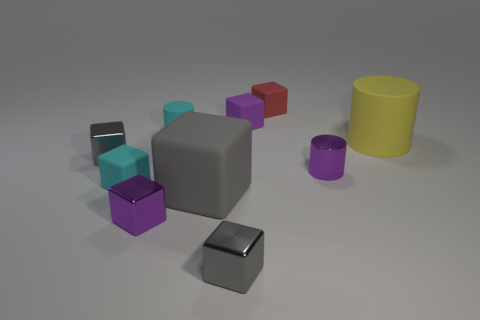There is a thing that is both to the left of the tiny purple metal cylinder and to the right of the small purple matte thing; what is its size?
Make the answer very short. Small. What shape is the small shiny thing that is the same color as the tiny metallic cylinder?
Your answer should be compact. Cube. What color is the shiny cylinder?
Provide a short and direct response. Purple. There is a gray cube behind the gray rubber thing; what size is it?
Ensure brevity in your answer.  Small. There is a large object that is on the right side of the small gray block that is in front of the large gray matte object; how many large gray blocks are behind it?
Your answer should be compact. 0. The small thing behind the purple thing that is behind the large cylinder is what color?
Provide a succinct answer. Red. Is there a shiny block that has the same size as the purple cylinder?
Give a very brief answer. Yes. There is a red object right of the tiny cyan cube in front of the matte cylinder that is on the left side of the big cube; what is it made of?
Provide a short and direct response. Rubber. How many small red rubber blocks are in front of the small cyan matte cylinder behind the yellow thing?
Your response must be concise. 0. Does the rubber cylinder that is right of the red block have the same size as the small purple metallic cylinder?
Make the answer very short. No. 